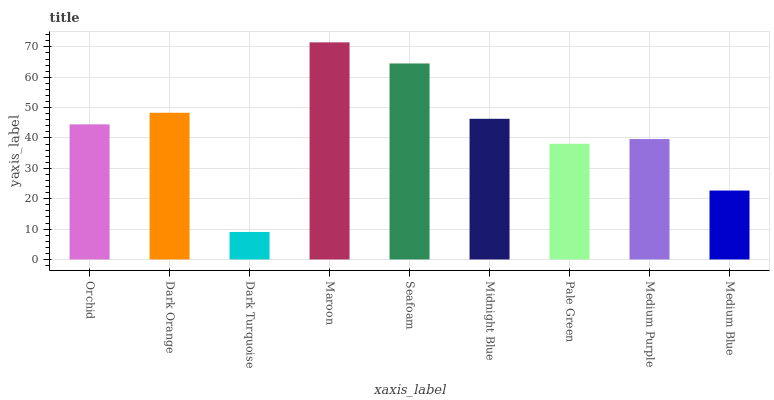Is Dark Turquoise the minimum?
Answer yes or no. Yes. Is Maroon the maximum?
Answer yes or no. Yes. Is Dark Orange the minimum?
Answer yes or no. No. Is Dark Orange the maximum?
Answer yes or no. No. Is Dark Orange greater than Orchid?
Answer yes or no. Yes. Is Orchid less than Dark Orange?
Answer yes or no. Yes. Is Orchid greater than Dark Orange?
Answer yes or no. No. Is Dark Orange less than Orchid?
Answer yes or no. No. Is Orchid the high median?
Answer yes or no. Yes. Is Orchid the low median?
Answer yes or no. Yes. Is Maroon the high median?
Answer yes or no. No. Is Maroon the low median?
Answer yes or no. No. 